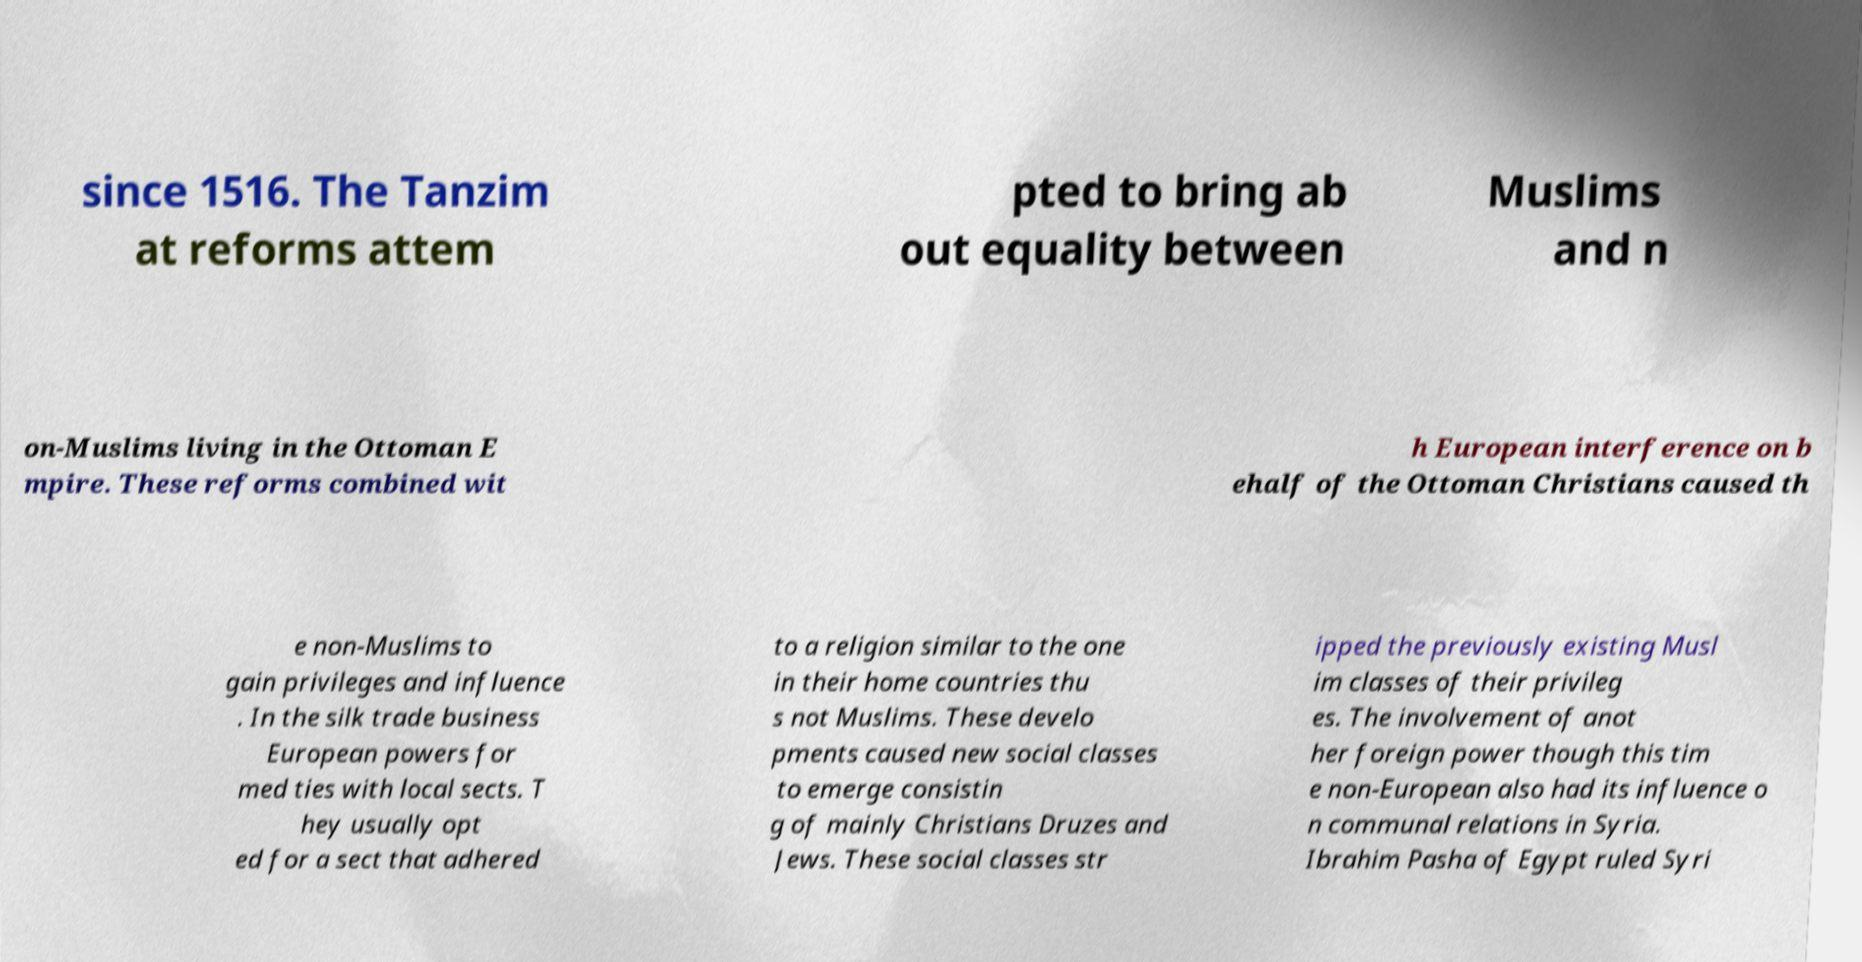What messages or text are displayed in this image? I need them in a readable, typed format. since 1516. The Tanzim at reforms attem pted to bring ab out equality between Muslims and n on-Muslims living in the Ottoman E mpire. These reforms combined wit h European interference on b ehalf of the Ottoman Christians caused th e non-Muslims to gain privileges and influence . In the silk trade business European powers for med ties with local sects. T hey usually opt ed for a sect that adhered to a religion similar to the one in their home countries thu s not Muslims. These develo pments caused new social classes to emerge consistin g of mainly Christians Druzes and Jews. These social classes str ipped the previously existing Musl im classes of their privileg es. The involvement of anot her foreign power though this tim e non-European also had its influence o n communal relations in Syria. Ibrahim Pasha of Egypt ruled Syri 